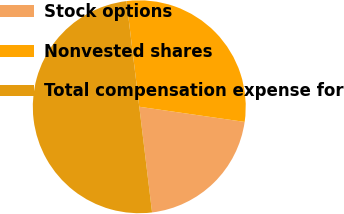Convert chart to OTSL. <chart><loc_0><loc_0><loc_500><loc_500><pie_chart><fcel>Stock options<fcel>Nonvested shares<fcel>Total compensation expense for<nl><fcel>20.81%<fcel>29.19%<fcel>50.0%<nl></chart> 